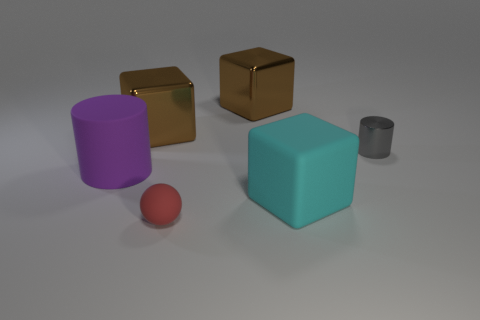There is a cylinder on the left side of the thing that is in front of the matte block; how many blocks are behind it?
Provide a short and direct response. 2. There is a matte object that is the same size as the gray cylinder; what is its color?
Offer a very short reply. Red. There is a tiny object right of the small object that is to the left of the metal thing that is on the right side of the cyan thing; what shape is it?
Make the answer very short. Cylinder. What number of large objects are on the right side of the large brown shiny cube that is on the left side of the small rubber thing?
Offer a very short reply. 2. Do the big matte thing that is in front of the matte cylinder and the big matte object that is to the left of the cyan rubber object have the same shape?
Your answer should be compact. No. There is a large cyan rubber object; how many matte objects are in front of it?
Your answer should be compact. 1. Is the material of the brown object that is on the right side of the tiny red ball the same as the big purple cylinder?
Offer a terse response. No. What color is the other metallic thing that is the same shape as the purple object?
Offer a terse response. Gray. The red object has what shape?
Ensure brevity in your answer.  Sphere. What number of things are cylinders or large brown objects?
Your answer should be compact. 4. 